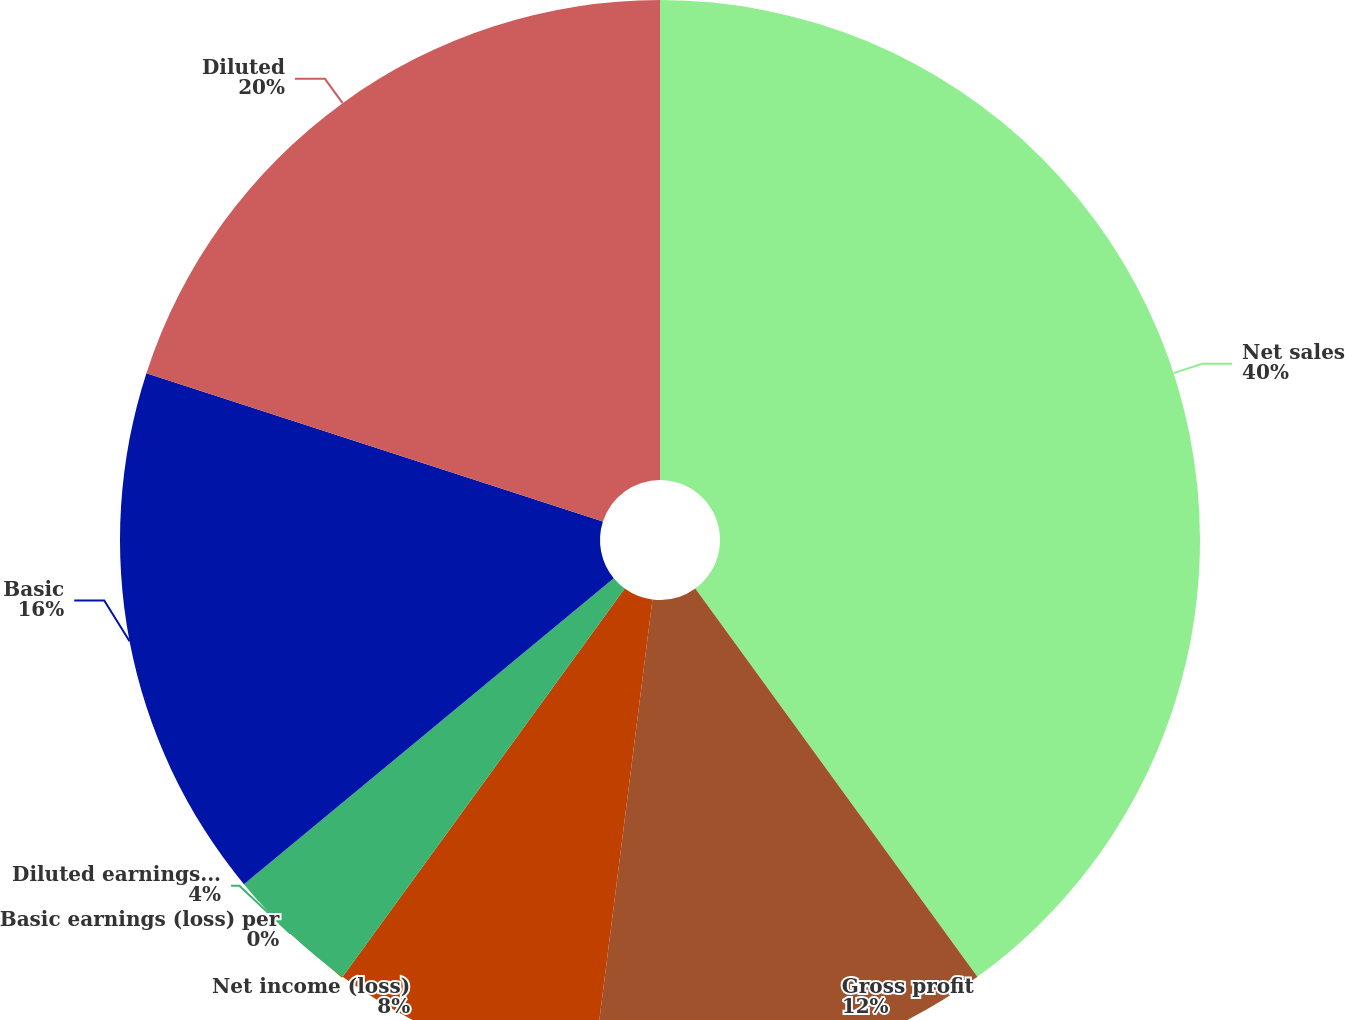Convert chart. <chart><loc_0><loc_0><loc_500><loc_500><pie_chart><fcel>Net sales<fcel>Gross profit<fcel>Net income (loss)<fcel>Basic earnings (loss) per<fcel>Diluted earnings (loss) per<fcel>Basic<fcel>Diluted<nl><fcel>40.0%<fcel>12.0%<fcel>8.0%<fcel>0.0%<fcel>4.0%<fcel>16.0%<fcel>20.0%<nl></chart> 